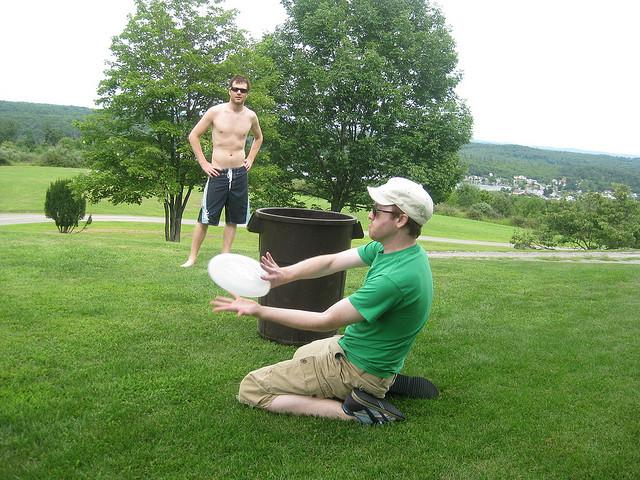What is the man wearing a hat doing?

Choices:
A) playing roshambo
B) holding plate
C) catching frisbee
D) throwing frisbee catching frisbee 